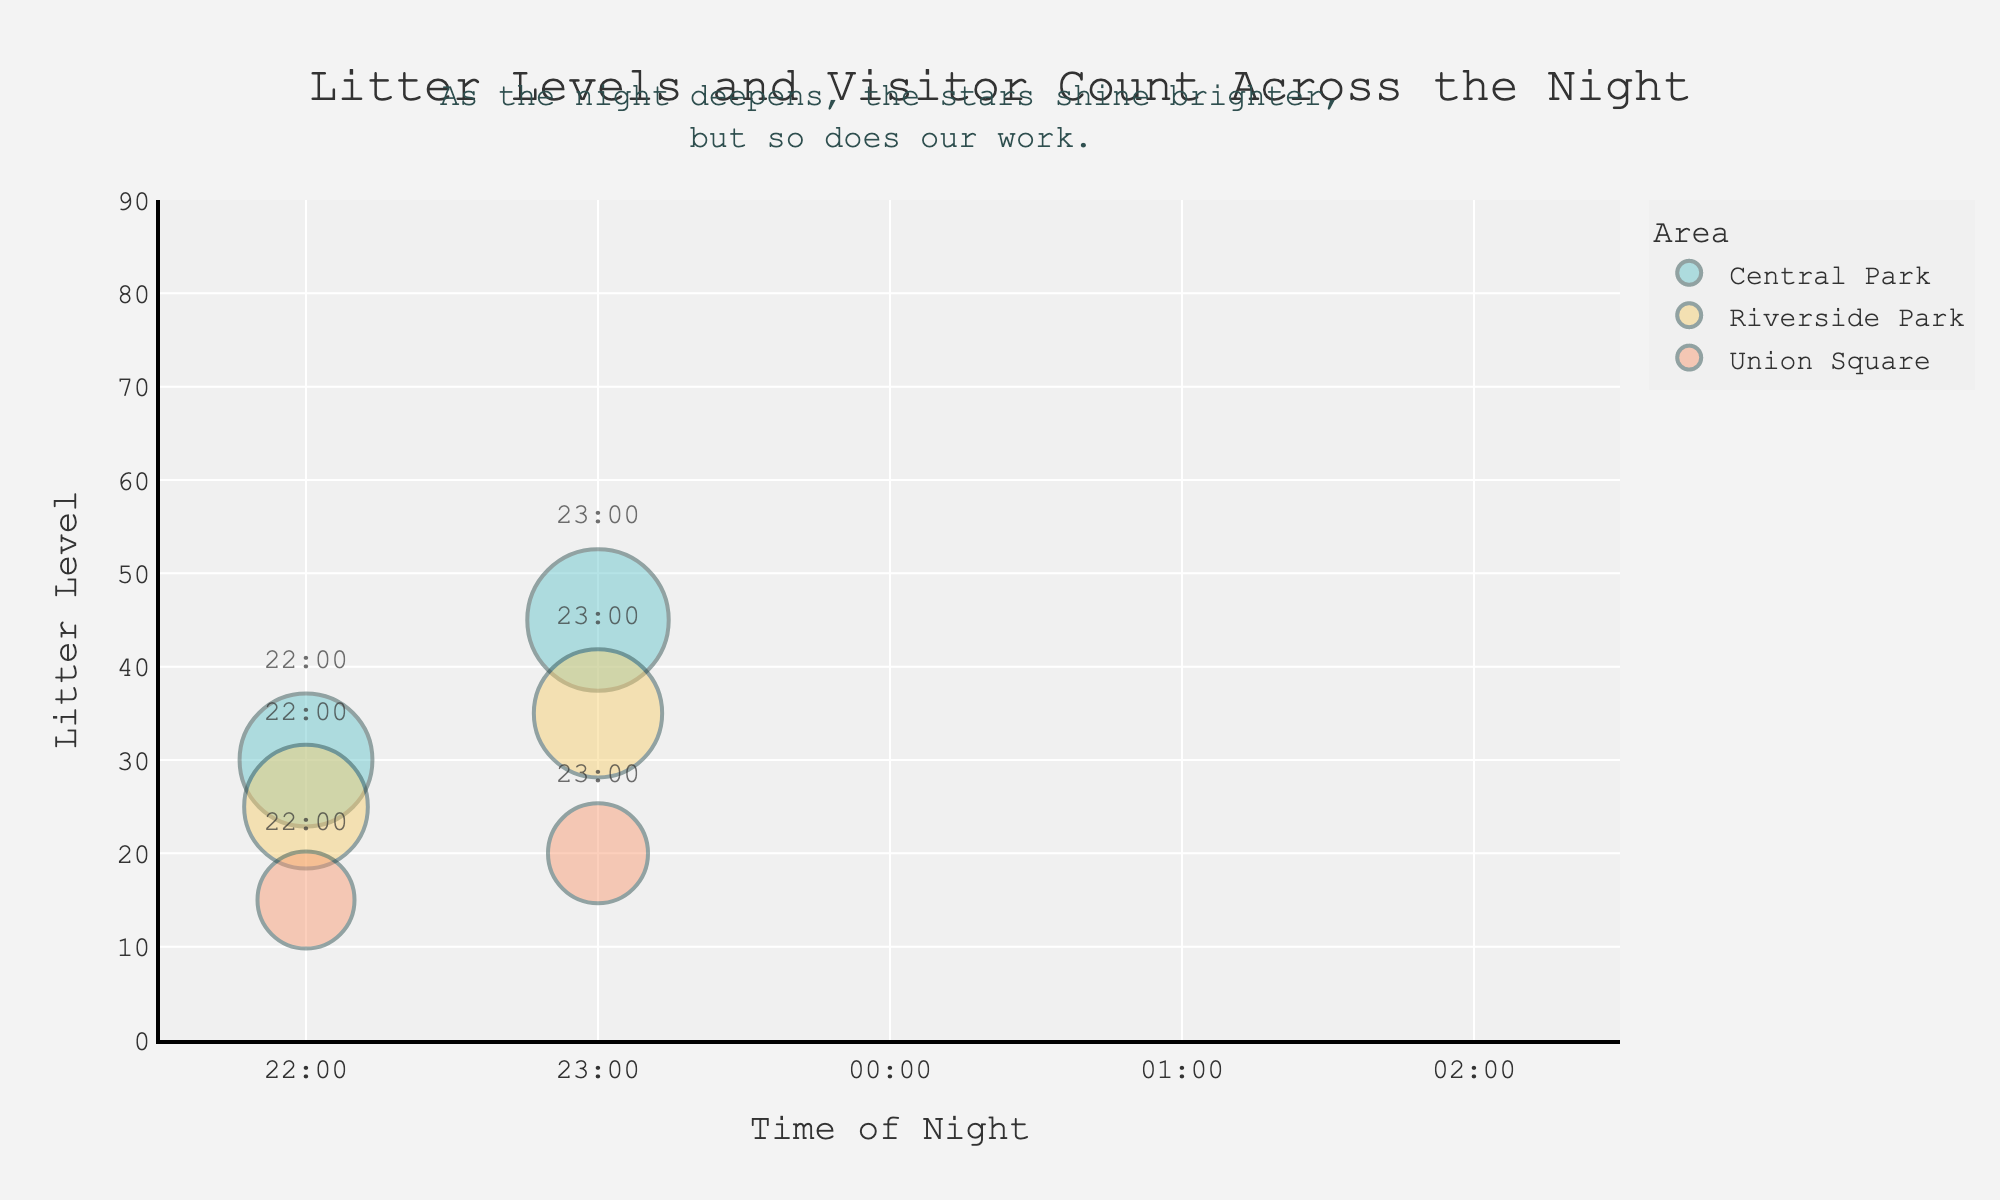What's the main title of the chart? The main title is written at the top of the chart and summarizes what the chart is about.
Answer: Litter Levels and Visitor Count Across the Night What are the x-axis and y-axis representing? The x-axis and y-axis labels tell us what variables are being plotted. The x-axis represents 'Time of Night', and the y-axis represents 'Litter Level'.
Answer: Time of Night and Litter Level How does the litter level change in Central Park from 22:00 to 02:00? Follow the bubbles for Central Park along the x-axis from 22:00 to 02:00 and observe their y-coordinates representing litter levels. It starts at 30 at 22:00, increasing to 85 by 02:00.
Answer: Increases from 30 to 85 Which area has the highest litter level at 23:00? Look at the 23:00 mark on the x-axis and find the bubble with the highest y-coordinate (litter level) for that time.
Answer: Central Park What is the range of the x-axis? Check the minimum and maximum values shown on the x-axis to determine the range. It ranges from 21.5 to 26.5, covering the times from 22:00 to 02:00.
Answer: 21.5 to 26.5 Which area shows the steepest increase in litter level from 22:00 to 23:00? Compare the slopes of the lines (indicated by the rise in y-coordinate over the one-hour period) for each area. Central Park's litter level rises from 30 to 45, Riverside Park from 25 to 35, and Union Square from 15 to 20. The steepest slope is for Central Park.
Answer: Central Park How many visitors are in Union Square at 23:00? The size of the bubble at the 23:00 mark for Union Square indicates the number of visitors. The bubble size represents 85 visitors.
Answer: 85 visitors Which time shows the highest litter level in Riverside Park? Identify the Riverside Park bubbles and compare their y-coordinates. The highest one is at 02:00 with a litter level of 70.
Answer: 02:00 How does the total number of visitors change in Central Park from 22:00 to 02:00? Track the size of the bubbles for Central Park along the x-axis from 22:00 to 02:00. At 22:00, there are 150 visitors, and it decreases to 80 by 02:00.
Answer: Decreases from 150 to 80 At 01:00, which area has the smallest number of visitors, and what is the corresponding litter level? Compare the bubble sizes for the three areas at 01:00. Union Square, the smallest bubble, has 45 visitors with a litter level of 30.
Answer: Union Square, Litter Level 30 